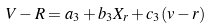Convert formula to latex. <formula><loc_0><loc_0><loc_500><loc_500>V - R = a _ { 3 } + b _ { 3 } X _ { r } + c _ { 3 } ( v - r )</formula> 